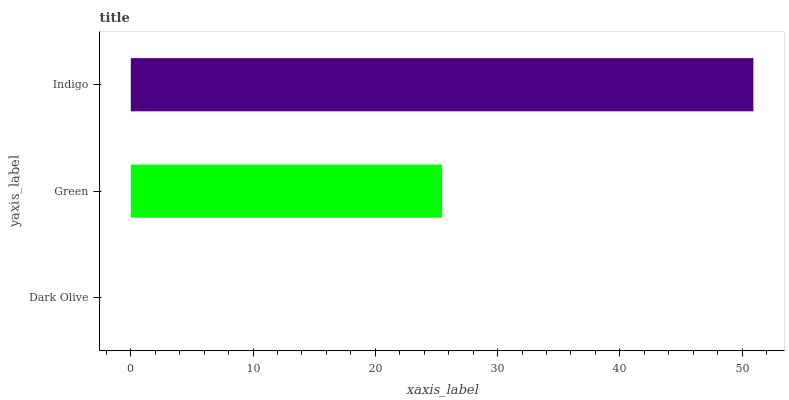Is Dark Olive the minimum?
Answer yes or no. Yes. Is Indigo the maximum?
Answer yes or no. Yes. Is Green the minimum?
Answer yes or no. No. Is Green the maximum?
Answer yes or no. No. Is Green greater than Dark Olive?
Answer yes or no. Yes. Is Dark Olive less than Green?
Answer yes or no. Yes. Is Dark Olive greater than Green?
Answer yes or no. No. Is Green less than Dark Olive?
Answer yes or no. No. Is Green the high median?
Answer yes or no. Yes. Is Green the low median?
Answer yes or no. Yes. Is Dark Olive the high median?
Answer yes or no. No. Is Dark Olive the low median?
Answer yes or no. No. 